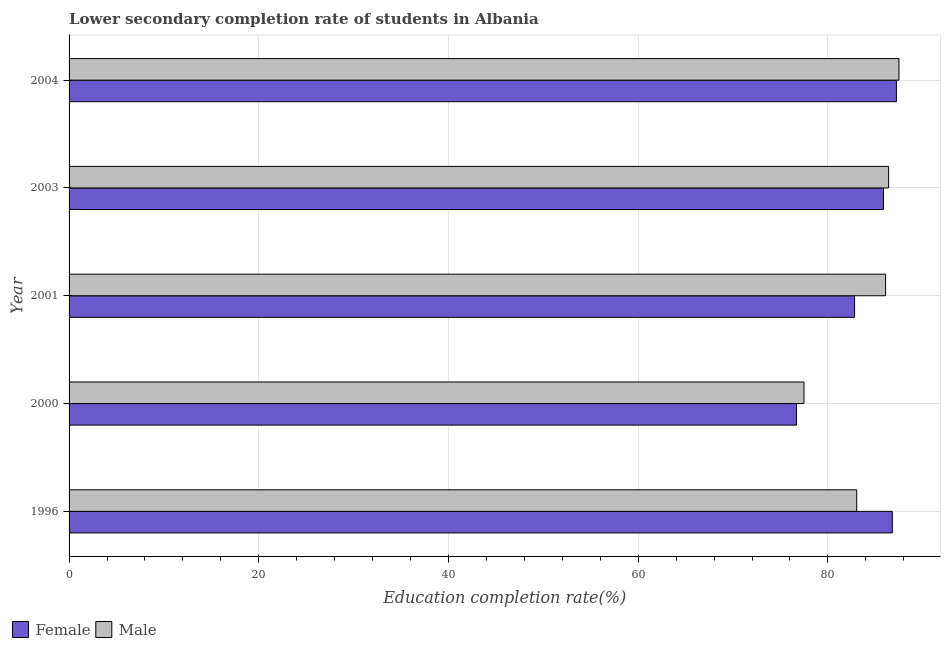Are the number of bars on each tick of the Y-axis equal?
Ensure brevity in your answer.  Yes. How many bars are there on the 3rd tick from the bottom?
Your answer should be compact. 2. What is the label of the 2nd group of bars from the top?
Keep it short and to the point. 2003. In how many cases, is the number of bars for a given year not equal to the number of legend labels?
Your answer should be compact. 0. What is the education completion rate of female students in 2001?
Your answer should be very brief. 82.82. Across all years, what is the maximum education completion rate of male students?
Your answer should be compact. 87.5. Across all years, what is the minimum education completion rate of female students?
Give a very brief answer. 76.69. In which year was the education completion rate of female students minimum?
Offer a very short reply. 2000. What is the total education completion rate of male students in the graph?
Keep it short and to the point. 420.51. What is the difference between the education completion rate of female students in 1996 and that in 2004?
Your answer should be compact. -0.44. What is the difference between the education completion rate of male students in 2000 and the education completion rate of female students in 2003?
Your answer should be very brief. -8.38. What is the average education completion rate of male students per year?
Provide a succinct answer. 84.1. In the year 1996, what is the difference between the education completion rate of male students and education completion rate of female students?
Offer a terse response. -3.75. In how many years, is the education completion rate of male students greater than 72 %?
Offer a terse response. 5. What is the ratio of the education completion rate of male students in 2001 to that in 2003?
Ensure brevity in your answer.  1. Is the education completion rate of female students in 2001 less than that in 2003?
Your answer should be compact. Yes. Is the difference between the education completion rate of female students in 2001 and 2003 greater than the difference between the education completion rate of male students in 2001 and 2003?
Your answer should be compact. No. What is the difference between the highest and the second highest education completion rate of male students?
Provide a succinct answer. 1.09. What is the difference between the highest and the lowest education completion rate of female students?
Your answer should be compact. 10.54. What does the 1st bar from the top in 2000 represents?
Make the answer very short. Male. What does the 1st bar from the bottom in 2003 represents?
Make the answer very short. Female. Are all the bars in the graph horizontal?
Keep it short and to the point. Yes. How many years are there in the graph?
Your answer should be very brief. 5. Does the graph contain grids?
Give a very brief answer. Yes. How many legend labels are there?
Your response must be concise. 2. What is the title of the graph?
Your answer should be compact. Lower secondary completion rate of students in Albania. Does "Imports" appear as one of the legend labels in the graph?
Provide a succinct answer. No. What is the label or title of the X-axis?
Provide a succinct answer. Education completion rate(%). What is the Education completion rate(%) of Female in 1996?
Offer a very short reply. 86.79. What is the Education completion rate(%) in Male in 1996?
Your answer should be very brief. 83.04. What is the Education completion rate(%) in Female in 2000?
Provide a short and direct response. 76.69. What is the Education completion rate(%) in Male in 2000?
Your answer should be very brief. 77.48. What is the Education completion rate(%) of Female in 2001?
Offer a very short reply. 82.82. What is the Education completion rate(%) of Male in 2001?
Make the answer very short. 86.09. What is the Education completion rate(%) in Female in 2003?
Your response must be concise. 85.86. What is the Education completion rate(%) of Male in 2003?
Offer a very short reply. 86.4. What is the Education completion rate(%) in Female in 2004?
Give a very brief answer. 87.23. What is the Education completion rate(%) of Male in 2004?
Provide a succinct answer. 87.5. Across all years, what is the maximum Education completion rate(%) in Female?
Make the answer very short. 87.23. Across all years, what is the maximum Education completion rate(%) of Male?
Keep it short and to the point. 87.5. Across all years, what is the minimum Education completion rate(%) in Female?
Offer a terse response. 76.69. Across all years, what is the minimum Education completion rate(%) in Male?
Keep it short and to the point. 77.48. What is the total Education completion rate(%) in Female in the graph?
Keep it short and to the point. 419.39. What is the total Education completion rate(%) of Male in the graph?
Your answer should be very brief. 420.51. What is the difference between the Education completion rate(%) of Female in 1996 and that in 2000?
Ensure brevity in your answer.  10.1. What is the difference between the Education completion rate(%) in Male in 1996 and that in 2000?
Your answer should be very brief. 5.56. What is the difference between the Education completion rate(%) of Female in 1996 and that in 2001?
Offer a terse response. 3.97. What is the difference between the Education completion rate(%) of Male in 1996 and that in 2001?
Make the answer very short. -3.05. What is the difference between the Education completion rate(%) of Female in 1996 and that in 2003?
Offer a very short reply. 0.93. What is the difference between the Education completion rate(%) in Male in 1996 and that in 2003?
Offer a terse response. -3.36. What is the difference between the Education completion rate(%) of Female in 1996 and that in 2004?
Offer a terse response. -0.44. What is the difference between the Education completion rate(%) in Male in 1996 and that in 2004?
Your answer should be very brief. -4.46. What is the difference between the Education completion rate(%) of Female in 2000 and that in 2001?
Provide a short and direct response. -6.13. What is the difference between the Education completion rate(%) in Male in 2000 and that in 2001?
Your response must be concise. -8.6. What is the difference between the Education completion rate(%) of Female in 2000 and that in 2003?
Ensure brevity in your answer.  -9.17. What is the difference between the Education completion rate(%) of Male in 2000 and that in 2003?
Ensure brevity in your answer.  -8.92. What is the difference between the Education completion rate(%) in Female in 2000 and that in 2004?
Provide a succinct answer. -10.54. What is the difference between the Education completion rate(%) in Male in 2000 and that in 2004?
Make the answer very short. -10.02. What is the difference between the Education completion rate(%) of Female in 2001 and that in 2003?
Ensure brevity in your answer.  -3.05. What is the difference between the Education completion rate(%) of Male in 2001 and that in 2003?
Offer a terse response. -0.32. What is the difference between the Education completion rate(%) in Female in 2001 and that in 2004?
Offer a terse response. -4.41. What is the difference between the Education completion rate(%) of Male in 2001 and that in 2004?
Give a very brief answer. -1.41. What is the difference between the Education completion rate(%) in Female in 2003 and that in 2004?
Your response must be concise. -1.36. What is the difference between the Education completion rate(%) in Male in 2003 and that in 2004?
Give a very brief answer. -1.1. What is the difference between the Education completion rate(%) of Female in 1996 and the Education completion rate(%) of Male in 2000?
Keep it short and to the point. 9.31. What is the difference between the Education completion rate(%) of Female in 1996 and the Education completion rate(%) of Male in 2001?
Keep it short and to the point. 0.7. What is the difference between the Education completion rate(%) of Female in 1996 and the Education completion rate(%) of Male in 2003?
Offer a very short reply. 0.39. What is the difference between the Education completion rate(%) of Female in 1996 and the Education completion rate(%) of Male in 2004?
Keep it short and to the point. -0.71. What is the difference between the Education completion rate(%) in Female in 2000 and the Education completion rate(%) in Male in 2001?
Your answer should be very brief. -9.4. What is the difference between the Education completion rate(%) in Female in 2000 and the Education completion rate(%) in Male in 2003?
Give a very brief answer. -9.71. What is the difference between the Education completion rate(%) of Female in 2000 and the Education completion rate(%) of Male in 2004?
Provide a short and direct response. -10.81. What is the difference between the Education completion rate(%) of Female in 2001 and the Education completion rate(%) of Male in 2003?
Your response must be concise. -3.59. What is the difference between the Education completion rate(%) in Female in 2001 and the Education completion rate(%) in Male in 2004?
Offer a very short reply. -4.68. What is the difference between the Education completion rate(%) in Female in 2003 and the Education completion rate(%) in Male in 2004?
Your response must be concise. -1.64. What is the average Education completion rate(%) in Female per year?
Offer a very short reply. 83.88. What is the average Education completion rate(%) in Male per year?
Ensure brevity in your answer.  84.1. In the year 1996, what is the difference between the Education completion rate(%) in Female and Education completion rate(%) in Male?
Ensure brevity in your answer.  3.75. In the year 2000, what is the difference between the Education completion rate(%) of Female and Education completion rate(%) of Male?
Your response must be concise. -0.79. In the year 2001, what is the difference between the Education completion rate(%) of Female and Education completion rate(%) of Male?
Keep it short and to the point. -3.27. In the year 2003, what is the difference between the Education completion rate(%) in Female and Education completion rate(%) in Male?
Keep it short and to the point. -0.54. In the year 2004, what is the difference between the Education completion rate(%) in Female and Education completion rate(%) in Male?
Keep it short and to the point. -0.27. What is the ratio of the Education completion rate(%) of Female in 1996 to that in 2000?
Ensure brevity in your answer.  1.13. What is the ratio of the Education completion rate(%) in Male in 1996 to that in 2000?
Give a very brief answer. 1.07. What is the ratio of the Education completion rate(%) of Female in 1996 to that in 2001?
Make the answer very short. 1.05. What is the ratio of the Education completion rate(%) in Male in 1996 to that in 2001?
Offer a terse response. 0.96. What is the ratio of the Education completion rate(%) of Female in 1996 to that in 2003?
Provide a short and direct response. 1.01. What is the ratio of the Education completion rate(%) in Male in 1996 to that in 2003?
Provide a short and direct response. 0.96. What is the ratio of the Education completion rate(%) in Female in 1996 to that in 2004?
Give a very brief answer. 0.99. What is the ratio of the Education completion rate(%) of Male in 1996 to that in 2004?
Your answer should be very brief. 0.95. What is the ratio of the Education completion rate(%) of Female in 2000 to that in 2001?
Make the answer very short. 0.93. What is the ratio of the Education completion rate(%) in Male in 2000 to that in 2001?
Your response must be concise. 0.9. What is the ratio of the Education completion rate(%) of Female in 2000 to that in 2003?
Give a very brief answer. 0.89. What is the ratio of the Education completion rate(%) in Male in 2000 to that in 2003?
Make the answer very short. 0.9. What is the ratio of the Education completion rate(%) of Female in 2000 to that in 2004?
Your answer should be compact. 0.88. What is the ratio of the Education completion rate(%) of Male in 2000 to that in 2004?
Make the answer very short. 0.89. What is the ratio of the Education completion rate(%) of Female in 2001 to that in 2003?
Provide a short and direct response. 0.96. What is the ratio of the Education completion rate(%) of Male in 2001 to that in 2003?
Offer a very short reply. 1. What is the ratio of the Education completion rate(%) of Female in 2001 to that in 2004?
Keep it short and to the point. 0.95. What is the ratio of the Education completion rate(%) in Male in 2001 to that in 2004?
Provide a succinct answer. 0.98. What is the ratio of the Education completion rate(%) in Female in 2003 to that in 2004?
Your answer should be very brief. 0.98. What is the ratio of the Education completion rate(%) of Male in 2003 to that in 2004?
Your response must be concise. 0.99. What is the difference between the highest and the second highest Education completion rate(%) of Female?
Keep it short and to the point. 0.44. What is the difference between the highest and the second highest Education completion rate(%) in Male?
Make the answer very short. 1.1. What is the difference between the highest and the lowest Education completion rate(%) in Female?
Give a very brief answer. 10.54. What is the difference between the highest and the lowest Education completion rate(%) of Male?
Your answer should be compact. 10.02. 